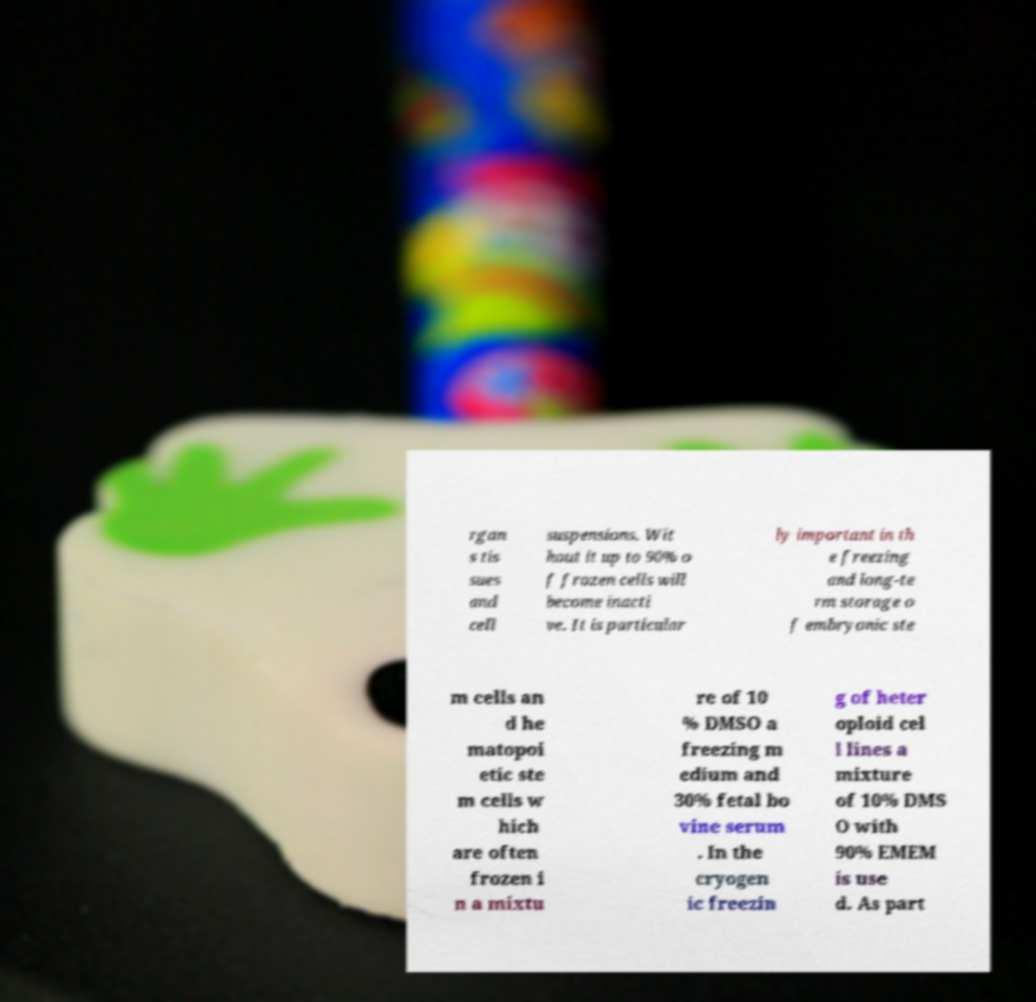Could you extract and type out the text from this image? rgan s tis sues and cell suspensions. Wit hout it up to 90% o f frozen cells will become inacti ve. It is particular ly important in th e freezing and long-te rm storage o f embryonic ste m cells an d he matopoi etic ste m cells w hich are often frozen i n a mixtu re of 10 % DMSO a freezing m edium and 30% fetal bo vine serum . In the cryogen ic freezin g of heter oploid cel l lines a mixture of 10% DMS O with 90% EMEM is use d. As part 